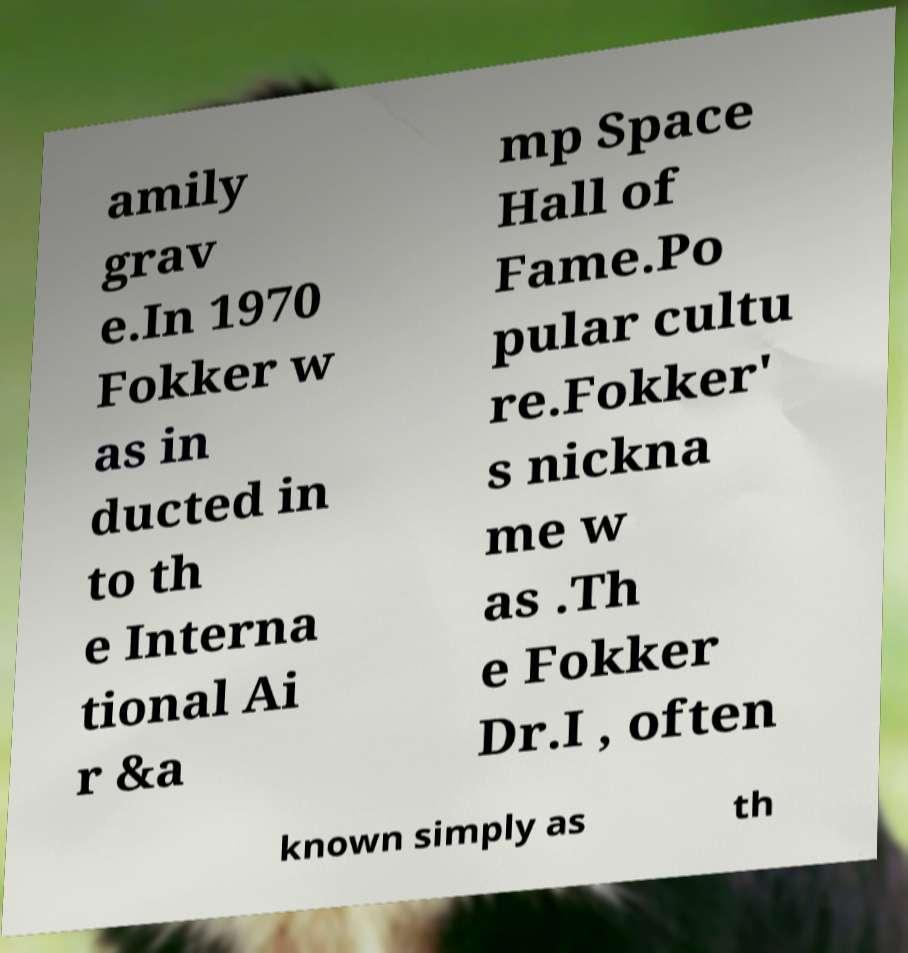Could you assist in decoding the text presented in this image and type it out clearly? amily grav e.In 1970 Fokker w as in ducted in to th e Interna tional Ai r &a mp Space Hall of Fame.Po pular cultu re.Fokker' s nickna me w as .Th e Fokker Dr.I , often known simply as th 